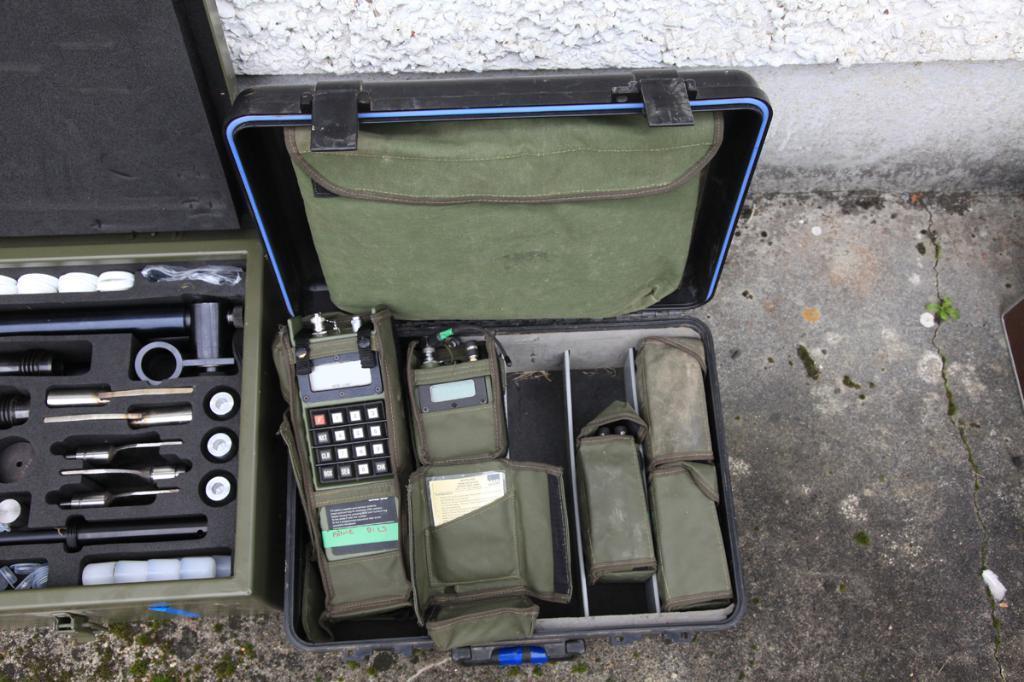Describe this image in one or two sentences. In this image, we can see some brief cases. Among them, we can see some devices in one brief case and some tools in the other brief case. We can see the ground and the wall. 